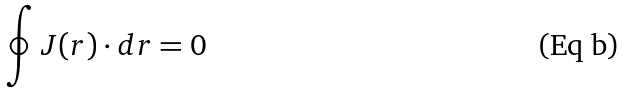<formula> <loc_0><loc_0><loc_500><loc_500>\oint { J } ( { r } ) \cdot d { r = 0 }</formula> 